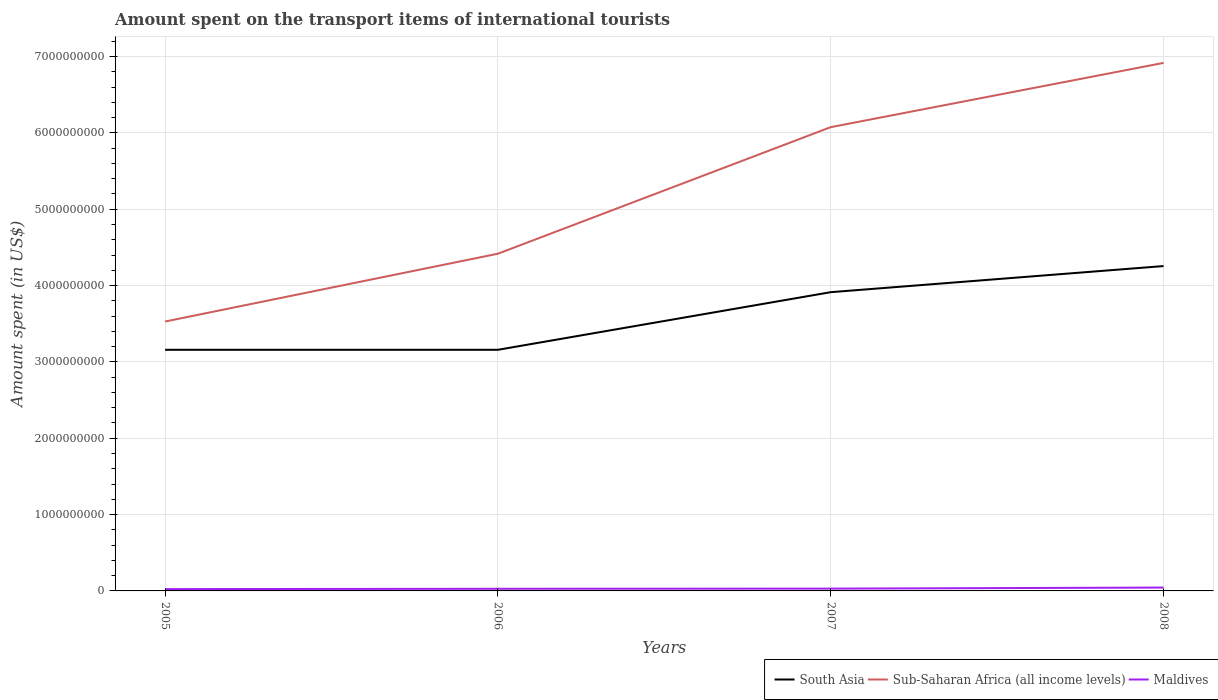How many different coloured lines are there?
Provide a short and direct response. 3. Across all years, what is the maximum amount spent on the transport items of international tourists in Sub-Saharan Africa (all income levels)?
Give a very brief answer. 3.53e+09. What is the total amount spent on the transport items of international tourists in South Asia in the graph?
Your answer should be very brief. -7.55e+08. What is the difference between the highest and the second highest amount spent on the transport items of international tourists in Maldives?
Provide a succinct answer. 2.00e+07. Is the amount spent on the transport items of international tourists in South Asia strictly greater than the amount spent on the transport items of international tourists in Sub-Saharan Africa (all income levels) over the years?
Give a very brief answer. Yes. How many lines are there?
Provide a succinct answer. 3. How many years are there in the graph?
Offer a very short reply. 4. Are the values on the major ticks of Y-axis written in scientific E-notation?
Keep it short and to the point. No. Does the graph contain grids?
Give a very brief answer. Yes. What is the title of the graph?
Provide a succinct answer. Amount spent on the transport items of international tourists. What is the label or title of the Y-axis?
Provide a succinct answer. Amount spent (in US$). What is the Amount spent (in US$) in South Asia in 2005?
Provide a succinct answer. 3.16e+09. What is the Amount spent (in US$) in Sub-Saharan Africa (all income levels) in 2005?
Your answer should be compact. 3.53e+09. What is the Amount spent (in US$) in Maldives in 2005?
Provide a short and direct response. 2.40e+07. What is the Amount spent (in US$) of South Asia in 2006?
Keep it short and to the point. 3.16e+09. What is the Amount spent (in US$) in Sub-Saharan Africa (all income levels) in 2006?
Keep it short and to the point. 4.42e+09. What is the Amount spent (in US$) of Maldives in 2006?
Offer a terse response. 2.80e+07. What is the Amount spent (in US$) in South Asia in 2007?
Your response must be concise. 3.91e+09. What is the Amount spent (in US$) of Sub-Saharan Africa (all income levels) in 2007?
Your response must be concise. 6.08e+09. What is the Amount spent (in US$) of Maldives in 2007?
Your answer should be compact. 3.00e+07. What is the Amount spent (in US$) of South Asia in 2008?
Ensure brevity in your answer.  4.26e+09. What is the Amount spent (in US$) in Sub-Saharan Africa (all income levels) in 2008?
Your answer should be very brief. 6.92e+09. What is the Amount spent (in US$) in Maldives in 2008?
Offer a terse response. 4.40e+07. Across all years, what is the maximum Amount spent (in US$) of South Asia?
Ensure brevity in your answer.  4.26e+09. Across all years, what is the maximum Amount spent (in US$) in Sub-Saharan Africa (all income levels)?
Provide a succinct answer. 6.92e+09. Across all years, what is the maximum Amount spent (in US$) in Maldives?
Your answer should be very brief. 4.40e+07. Across all years, what is the minimum Amount spent (in US$) of South Asia?
Your response must be concise. 3.16e+09. Across all years, what is the minimum Amount spent (in US$) in Sub-Saharan Africa (all income levels)?
Keep it short and to the point. 3.53e+09. Across all years, what is the minimum Amount spent (in US$) in Maldives?
Give a very brief answer. 2.40e+07. What is the total Amount spent (in US$) in South Asia in the graph?
Your answer should be compact. 1.45e+1. What is the total Amount spent (in US$) of Sub-Saharan Africa (all income levels) in the graph?
Keep it short and to the point. 2.09e+1. What is the total Amount spent (in US$) in Maldives in the graph?
Offer a terse response. 1.26e+08. What is the difference between the Amount spent (in US$) in South Asia in 2005 and that in 2006?
Your answer should be compact. 0. What is the difference between the Amount spent (in US$) of Sub-Saharan Africa (all income levels) in 2005 and that in 2006?
Your answer should be very brief. -8.88e+08. What is the difference between the Amount spent (in US$) in South Asia in 2005 and that in 2007?
Give a very brief answer. -7.55e+08. What is the difference between the Amount spent (in US$) of Sub-Saharan Africa (all income levels) in 2005 and that in 2007?
Provide a short and direct response. -2.55e+09. What is the difference between the Amount spent (in US$) in Maldives in 2005 and that in 2007?
Your response must be concise. -6.00e+06. What is the difference between the Amount spent (in US$) in South Asia in 2005 and that in 2008?
Make the answer very short. -1.10e+09. What is the difference between the Amount spent (in US$) of Sub-Saharan Africa (all income levels) in 2005 and that in 2008?
Provide a succinct answer. -3.39e+09. What is the difference between the Amount spent (in US$) of Maldives in 2005 and that in 2008?
Your answer should be very brief. -2.00e+07. What is the difference between the Amount spent (in US$) of South Asia in 2006 and that in 2007?
Your answer should be compact. -7.55e+08. What is the difference between the Amount spent (in US$) in Sub-Saharan Africa (all income levels) in 2006 and that in 2007?
Your answer should be very brief. -1.66e+09. What is the difference between the Amount spent (in US$) of South Asia in 2006 and that in 2008?
Give a very brief answer. -1.10e+09. What is the difference between the Amount spent (in US$) in Sub-Saharan Africa (all income levels) in 2006 and that in 2008?
Ensure brevity in your answer.  -2.50e+09. What is the difference between the Amount spent (in US$) of Maldives in 2006 and that in 2008?
Give a very brief answer. -1.60e+07. What is the difference between the Amount spent (in US$) in South Asia in 2007 and that in 2008?
Provide a succinct answer. -3.42e+08. What is the difference between the Amount spent (in US$) in Sub-Saharan Africa (all income levels) in 2007 and that in 2008?
Make the answer very short. -8.42e+08. What is the difference between the Amount spent (in US$) in Maldives in 2007 and that in 2008?
Give a very brief answer. -1.40e+07. What is the difference between the Amount spent (in US$) of South Asia in 2005 and the Amount spent (in US$) of Sub-Saharan Africa (all income levels) in 2006?
Ensure brevity in your answer.  -1.26e+09. What is the difference between the Amount spent (in US$) of South Asia in 2005 and the Amount spent (in US$) of Maldives in 2006?
Your answer should be very brief. 3.13e+09. What is the difference between the Amount spent (in US$) of Sub-Saharan Africa (all income levels) in 2005 and the Amount spent (in US$) of Maldives in 2006?
Provide a short and direct response. 3.50e+09. What is the difference between the Amount spent (in US$) in South Asia in 2005 and the Amount spent (in US$) in Sub-Saharan Africa (all income levels) in 2007?
Provide a short and direct response. -2.92e+09. What is the difference between the Amount spent (in US$) of South Asia in 2005 and the Amount spent (in US$) of Maldives in 2007?
Offer a very short reply. 3.13e+09. What is the difference between the Amount spent (in US$) in Sub-Saharan Africa (all income levels) in 2005 and the Amount spent (in US$) in Maldives in 2007?
Provide a succinct answer. 3.50e+09. What is the difference between the Amount spent (in US$) of South Asia in 2005 and the Amount spent (in US$) of Sub-Saharan Africa (all income levels) in 2008?
Your response must be concise. -3.76e+09. What is the difference between the Amount spent (in US$) of South Asia in 2005 and the Amount spent (in US$) of Maldives in 2008?
Your answer should be very brief. 3.11e+09. What is the difference between the Amount spent (in US$) of Sub-Saharan Africa (all income levels) in 2005 and the Amount spent (in US$) of Maldives in 2008?
Offer a terse response. 3.49e+09. What is the difference between the Amount spent (in US$) in South Asia in 2006 and the Amount spent (in US$) in Sub-Saharan Africa (all income levels) in 2007?
Provide a succinct answer. -2.92e+09. What is the difference between the Amount spent (in US$) in South Asia in 2006 and the Amount spent (in US$) in Maldives in 2007?
Give a very brief answer. 3.13e+09. What is the difference between the Amount spent (in US$) in Sub-Saharan Africa (all income levels) in 2006 and the Amount spent (in US$) in Maldives in 2007?
Keep it short and to the point. 4.39e+09. What is the difference between the Amount spent (in US$) of South Asia in 2006 and the Amount spent (in US$) of Sub-Saharan Africa (all income levels) in 2008?
Your answer should be very brief. -3.76e+09. What is the difference between the Amount spent (in US$) of South Asia in 2006 and the Amount spent (in US$) of Maldives in 2008?
Keep it short and to the point. 3.11e+09. What is the difference between the Amount spent (in US$) in Sub-Saharan Africa (all income levels) in 2006 and the Amount spent (in US$) in Maldives in 2008?
Offer a terse response. 4.37e+09. What is the difference between the Amount spent (in US$) in South Asia in 2007 and the Amount spent (in US$) in Sub-Saharan Africa (all income levels) in 2008?
Ensure brevity in your answer.  -3.00e+09. What is the difference between the Amount spent (in US$) in South Asia in 2007 and the Amount spent (in US$) in Maldives in 2008?
Give a very brief answer. 3.87e+09. What is the difference between the Amount spent (in US$) in Sub-Saharan Africa (all income levels) in 2007 and the Amount spent (in US$) in Maldives in 2008?
Provide a short and direct response. 6.03e+09. What is the average Amount spent (in US$) in South Asia per year?
Ensure brevity in your answer.  3.62e+09. What is the average Amount spent (in US$) in Sub-Saharan Africa (all income levels) per year?
Ensure brevity in your answer.  5.24e+09. What is the average Amount spent (in US$) of Maldives per year?
Provide a succinct answer. 3.15e+07. In the year 2005, what is the difference between the Amount spent (in US$) of South Asia and Amount spent (in US$) of Sub-Saharan Africa (all income levels)?
Make the answer very short. -3.71e+08. In the year 2005, what is the difference between the Amount spent (in US$) of South Asia and Amount spent (in US$) of Maldives?
Give a very brief answer. 3.13e+09. In the year 2005, what is the difference between the Amount spent (in US$) of Sub-Saharan Africa (all income levels) and Amount spent (in US$) of Maldives?
Your answer should be very brief. 3.51e+09. In the year 2006, what is the difference between the Amount spent (in US$) of South Asia and Amount spent (in US$) of Sub-Saharan Africa (all income levels)?
Provide a succinct answer. -1.26e+09. In the year 2006, what is the difference between the Amount spent (in US$) in South Asia and Amount spent (in US$) in Maldives?
Provide a short and direct response. 3.13e+09. In the year 2006, what is the difference between the Amount spent (in US$) of Sub-Saharan Africa (all income levels) and Amount spent (in US$) of Maldives?
Your response must be concise. 4.39e+09. In the year 2007, what is the difference between the Amount spent (in US$) of South Asia and Amount spent (in US$) of Sub-Saharan Africa (all income levels)?
Provide a short and direct response. -2.16e+09. In the year 2007, what is the difference between the Amount spent (in US$) in South Asia and Amount spent (in US$) in Maldives?
Keep it short and to the point. 3.88e+09. In the year 2007, what is the difference between the Amount spent (in US$) in Sub-Saharan Africa (all income levels) and Amount spent (in US$) in Maldives?
Provide a succinct answer. 6.05e+09. In the year 2008, what is the difference between the Amount spent (in US$) of South Asia and Amount spent (in US$) of Sub-Saharan Africa (all income levels)?
Provide a short and direct response. -2.66e+09. In the year 2008, what is the difference between the Amount spent (in US$) in South Asia and Amount spent (in US$) in Maldives?
Give a very brief answer. 4.21e+09. In the year 2008, what is the difference between the Amount spent (in US$) in Sub-Saharan Africa (all income levels) and Amount spent (in US$) in Maldives?
Provide a succinct answer. 6.87e+09. What is the ratio of the Amount spent (in US$) of Sub-Saharan Africa (all income levels) in 2005 to that in 2006?
Your answer should be compact. 0.8. What is the ratio of the Amount spent (in US$) of Maldives in 2005 to that in 2006?
Your answer should be compact. 0.86. What is the ratio of the Amount spent (in US$) of South Asia in 2005 to that in 2007?
Ensure brevity in your answer.  0.81. What is the ratio of the Amount spent (in US$) in Sub-Saharan Africa (all income levels) in 2005 to that in 2007?
Provide a short and direct response. 0.58. What is the ratio of the Amount spent (in US$) of Maldives in 2005 to that in 2007?
Provide a succinct answer. 0.8. What is the ratio of the Amount spent (in US$) in South Asia in 2005 to that in 2008?
Your answer should be compact. 0.74. What is the ratio of the Amount spent (in US$) of Sub-Saharan Africa (all income levels) in 2005 to that in 2008?
Your answer should be compact. 0.51. What is the ratio of the Amount spent (in US$) in Maldives in 2005 to that in 2008?
Provide a short and direct response. 0.55. What is the ratio of the Amount spent (in US$) in South Asia in 2006 to that in 2007?
Make the answer very short. 0.81. What is the ratio of the Amount spent (in US$) in Sub-Saharan Africa (all income levels) in 2006 to that in 2007?
Give a very brief answer. 0.73. What is the ratio of the Amount spent (in US$) of South Asia in 2006 to that in 2008?
Offer a very short reply. 0.74. What is the ratio of the Amount spent (in US$) in Sub-Saharan Africa (all income levels) in 2006 to that in 2008?
Offer a very short reply. 0.64. What is the ratio of the Amount spent (in US$) of Maldives in 2006 to that in 2008?
Offer a very short reply. 0.64. What is the ratio of the Amount spent (in US$) of South Asia in 2007 to that in 2008?
Make the answer very short. 0.92. What is the ratio of the Amount spent (in US$) of Sub-Saharan Africa (all income levels) in 2007 to that in 2008?
Offer a terse response. 0.88. What is the ratio of the Amount spent (in US$) in Maldives in 2007 to that in 2008?
Give a very brief answer. 0.68. What is the difference between the highest and the second highest Amount spent (in US$) in South Asia?
Offer a very short reply. 3.42e+08. What is the difference between the highest and the second highest Amount spent (in US$) of Sub-Saharan Africa (all income levels)?
Your answer should be very brief. 8.42e+08. What is the difference between the highest and the second highest Amount spent (in US$) of Maldives?
Ensure brevity in your answer.  1.40e+07. What is the difference between the highest and the lowest Amount spent (in US$) of South Asia?
Provide a succinct answer. 1.10e+09. What is the difference between the highest and the lowest Amount spent (in US$) in Sub-Saharan Africa (all income levels)?
Ensure brevity in your answer.  3.39e+09. 